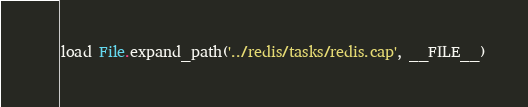<code> <loc_0><loc_0><loc_500><loc_500><_Ruby_>load File.expand_path('../redis/tasks/redis.cap', __FILE__)</code> 